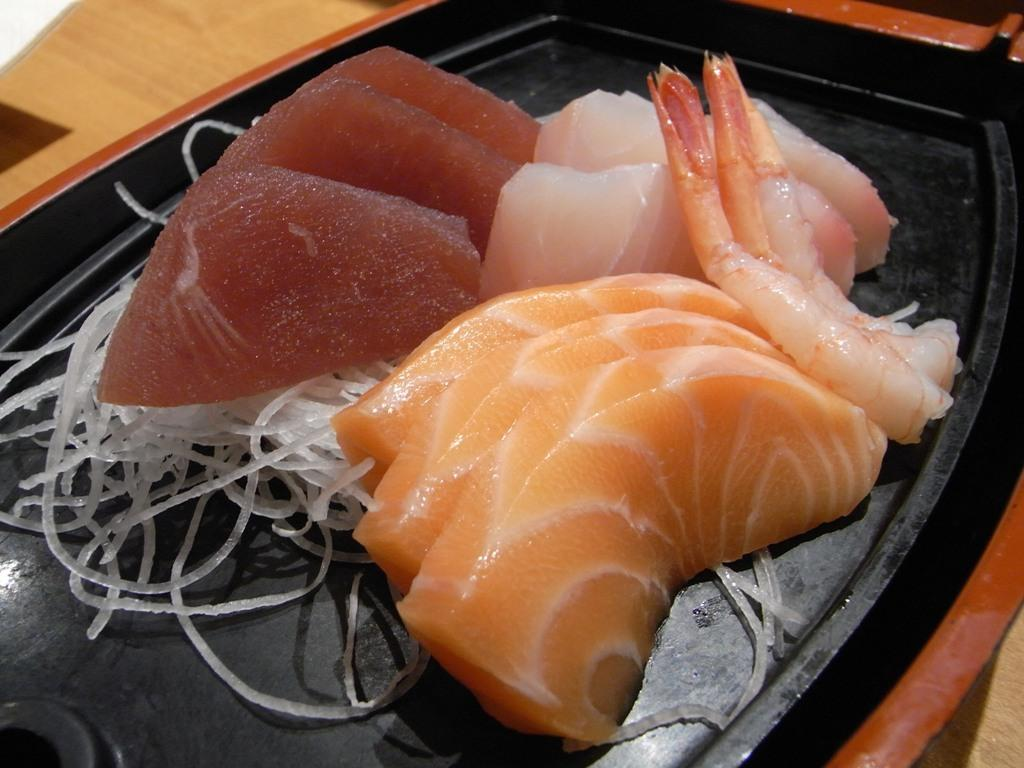What color is the plate in the image? The plate in the image is black. What is on the plate? The plate contains meat and onion slices. What is the surface beneath the plate? The plate is on a brown color surface. Are there any snakes visible on the plate in the image? No, there are no snakes visible on the plate in the image. 